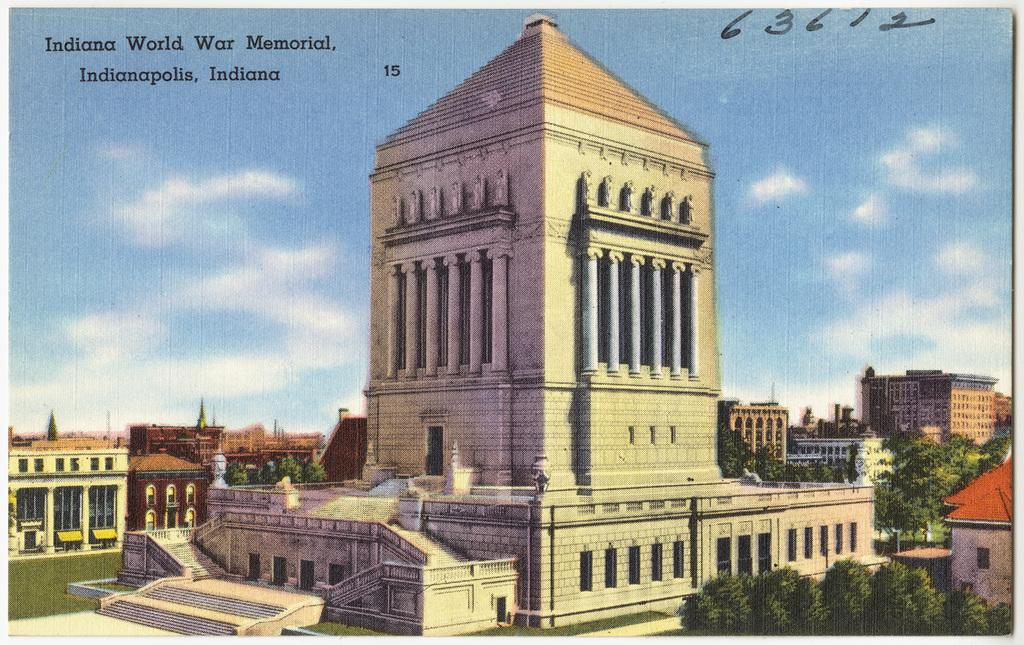<image>
Write a terse but informative summary of the picture. A drawing of a war memorial for Indianapolis Indiana. 